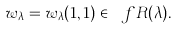<formula> <loc_0><loc_0><loc_500><loc_500>w _ { \lambda } = w _ { \lambda } ( 1 , 1 ) \in \ f R ( \lambda ) .</formula> 